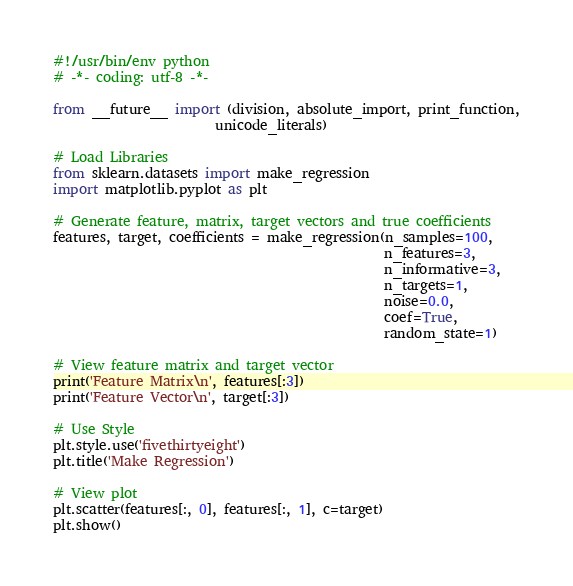<code> <loc_0><loc_0><loc_500><loc_500><_Python_>#!/usr/bin/env python
# -*- coding: utf-8 -*-

from __future__ import (division, absolute_import, print_function,
                        unicode_literals)

# Load Libraries
from sklearn.datasets import make_regression
import matplotlib.pyplot as plt

# Generate feature, matrix, target vectors and true coefficients
features, target, coefficients = make_regression(n_samples=100,
                                                 n_features=3,
                                                 n_informative=3,
                                                 n_targets=1,
                                                 noise=0.0,
                                                 coef=True,
                                                 random_state=1)

# View feature matrix and target vector
print('Feature Matrix\n', features[:3])
print('Feature Vector\n', target[:3])

# Use Style
plt.style.use('fivethirtyeight')
plt.title('Make Regression')

# View plot
plt.scatter(features[:, 0], features[:, 1], c=target)
plt.show()
</code> 